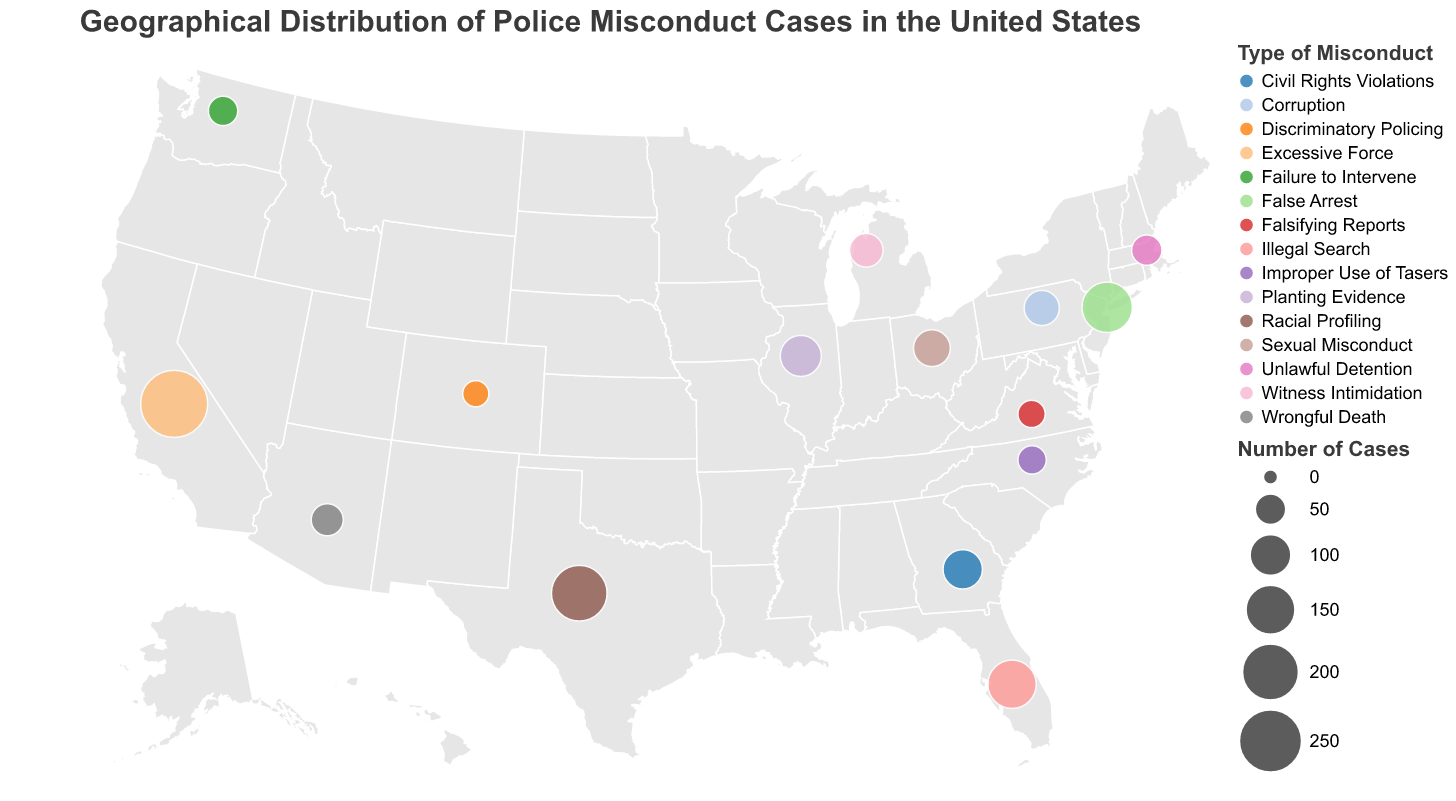What's the title of the figure? The title is displayed at the top of the figure. It reads "Geographical Distribution of Police Misconduct Cases in the United States".
Answer: Geographical Distribution of Police Misconduct Cases in the United States How many police misconduct cases are there in California? The data point for California indicates that the number of police misconduct cases is displayed as 287.
Answer: 287 Which state has the highest number of police misconduct cases? By comparing the sizes of the circles, California has the largest circle, indicating the highest number of cases.
Answer: California Which type of police misconduct has the highest number of cases in New York? By examining the tooltip for New York, the type of police misconduct is listed as "False Arrest" with 156 cases.
Answer: False Arrest What is the latitude and longitude of Texas in the figure? The data point for Texas shows the latitude as 31.9686 and the longitude as -99.9018.
Answer: 31.9686, -99.9018 Compare the number of police misconduct cases in Texas and Ohio. Which state has more cases? The data points indicate Texas has 193 cases while Ohio has 76 cases. Therefore, Texas has more cases.
Answer: Texas What is the total number of police misconduct cases in states east of the Mississippi River? The states east of the Mississippi River and their cases are: New York (156), Florida (142), Illinois (98), Georgia (89), Ohio (76), Pennsylvania (68), North Carolina (39), Virginia (35). Summing these gives 156 + 142 + 98 + 89 + 76 + 68 + 39 + 35 = 703.
Answer: 703 Which state has the least number of police misconduct cases and what type of misconduct is it associated with? By comparing the number of cases, Colorado has the least with 31 cases. The type of misconduct is "Discriminatory Policing".
Answer: Colorado, Discriminatory Policing How many states have reported cases of "Witness Intimidation"? The tooltip for Michigan indicates "Witness Intimidation" as the misconduct type. No other states show this.
Answer: 1 What is the average number of police misconduct cases across all listed states? Adding the cases: 287 + 193 + 156 + 142 + 98 + 89 + 76 + 68 + 61 + 54 + 47 + 43 + 39 + 35 + 31 = 1419. Dividing by 15 states gives 1419/15 = 94.6 (rounded to one decimal place).
Answer: 94.6 